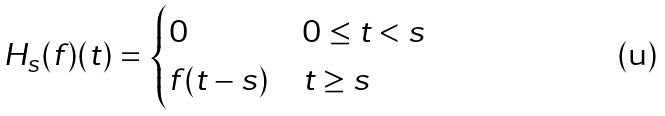<formula> <loc_0><loc_0><loc_500><loc_500>H _ { s } ( f ) ( t ) & = \begin{cases} 0 & 0 \leq t < s \\ f ( t - s ) & t \geq s \end{cases}</formula> 